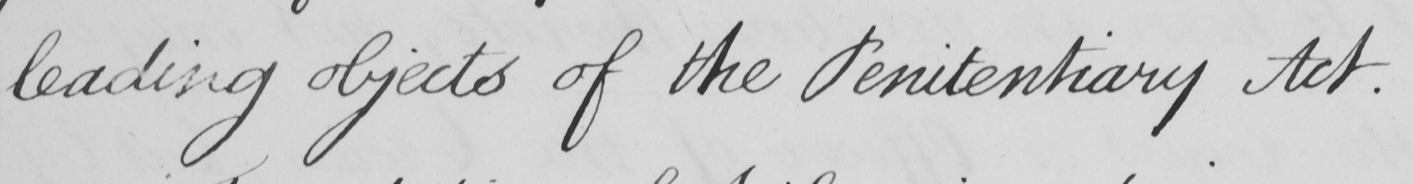Transcribe the text shown in this historical manuscript line. leading objects of the Penitentiary Act . 